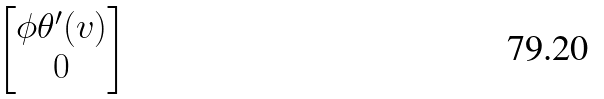Convert formula to latex. <formula><loc_0><loc_0><loc_500><loc_500>\begin{bmatrix} \phi \theta ^ { \prime } ( v ) \\ 0 \end{bmatrix}</formula> 